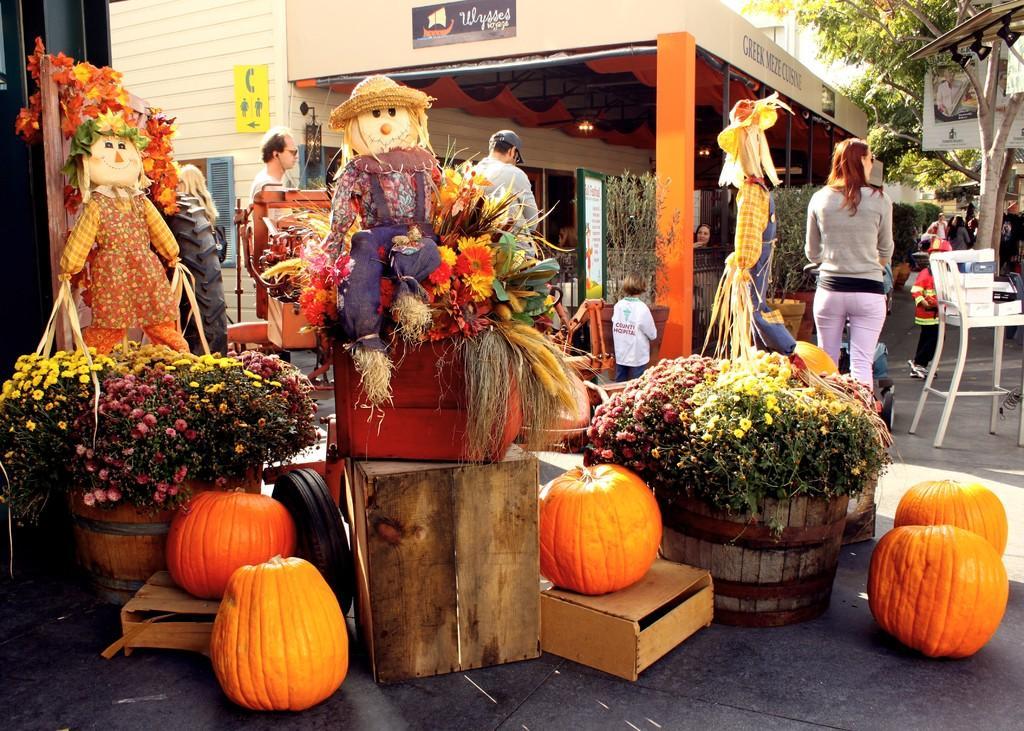Can you describe this image briefly? In this image there are so many plant pots are decorated on the road around them there are some pumpkins and also there are some dolls with them, behind them there is a building, trees and some people walking on the road. 